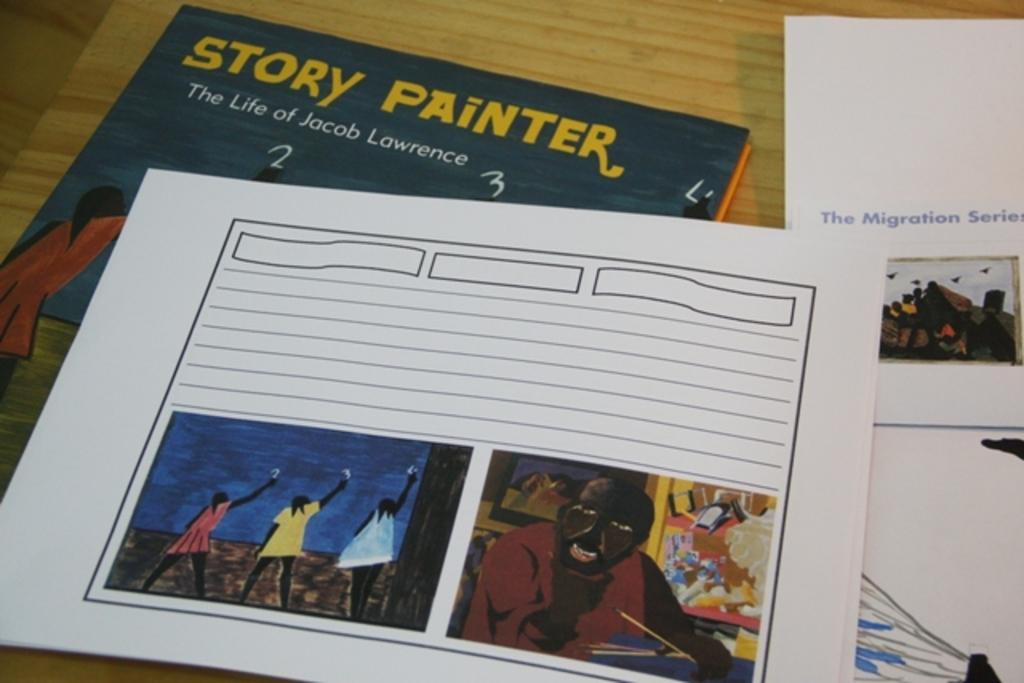<image>
Write a terse but informative summary of the picture. A book placed behind a paper that depicts the life of Jacob Lawrence. 